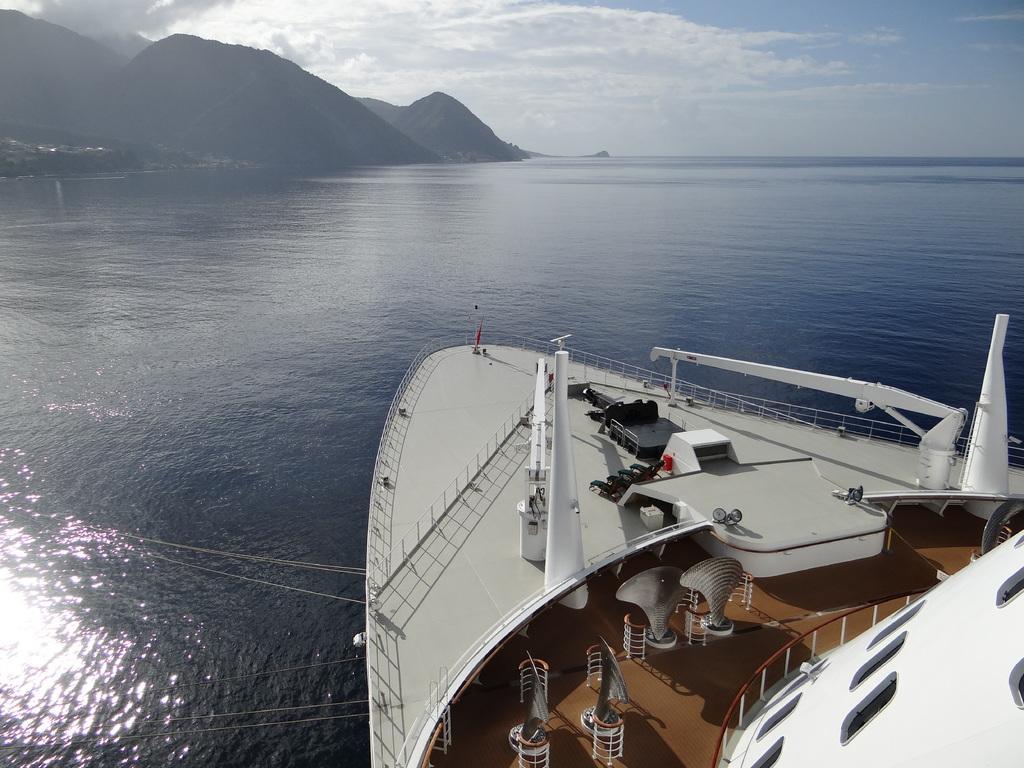Please provide a concise description of this image. This image is clicked in an ocean. To the right, there is a big ship in white color. At the bottom, there is water. In the background, there are mountains along with plants. At the top, there is sky along with clouds. 